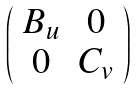Convert formula to latex. <formula><loc_0><loc_0><loc_500><loc_500>\left ( \begin{array} { c c } B _ { u } & 0 \\ 0 & C _ { v } \\ \end{array} \right )</formula> 